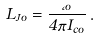Convert formula to latex. <formula><loc_0><loc_0><loc_500><loc_500>L _ { J o } = \frac { \Phi _ { o } } { 4 \pi I _ { c o } } \, .</formula> 